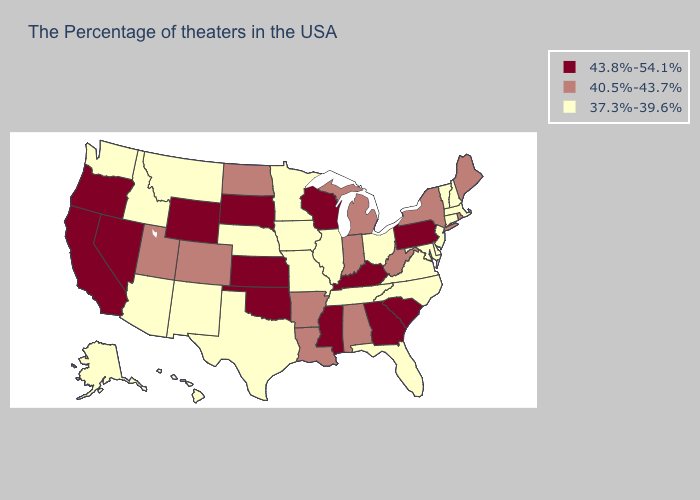Among the states that border Indiana , does Michigan have the lowest value?
Answer briefly. No. How many symbols are there in the legend?
Concise answer only. 3. Does the map have missing data?
Answer briefly. No. Among the states that border New Jersey , which have the highest value?
Write a very short answer. Pennsylvania. Does the map have missing data?
Answer briefly. No. Does the map have missing data?
Concise answer only. No. Name the states that have a value in the range 37.3%-39.6%?
Quick response, please. Massachusetts, New Hampshire, Vermont, Connecticut, New Jersey, Delaware, Maryland, Virginia, North Carolina, Ohio, Florida, Tennessee, Illinois, Missouri, Minnesota, Iowa, Nebraska, Texas, New Mexico, Montana, Arizona, Idaho, Washington, Alaska, Hawaii. What is the value of Hawaii?
Give a very brief answer. 37.3%-39.6%. Name the states that have a value in the range 40.5%-43.7%?
Be succinct. Maine, Rhode Island, New York, West Virginia, Michigan, Indiana, Alabama, Louisiana, Arkansas, North Dakota, Colorado, Utah. Name the states that have a value in the range 37.3%-39.6%?
Short answer required. Massachusetts, New Hampshire, Vermont, Connecticut, New Jersey, Delaware, Maryland, Virginia, North Carolina, Ohio, Florida, Tennessee, Illinois, Missouri, Minnesota, Iowa, Nebraska, Texas, New Mexico, Montana, Arizona, Idaho, Washington, Alaska, Hawaii. Name the states that have a value in the range 37.3%-39.6%?
Short answer required. Massachusetts, New Hampshire, Vermont, Connecticut, New Jersey, Delaware, Maryland, Virginia, North Carolina, Ohio, Florida, Tennessee, Illinois, Missouri, Minnesota, Iowa, Nebraska, Texas, New Mexico, Montana, Arizona, Idaho, Washington, Alaska, Hawaii. Name the states that have a value in the range 40.5%-43.7%?
Short answer required. Maine, Rhode Island, New York, West Virginia, Michigan, Indiana, Alabama, Louisiana, Arkansas, North Dakota, Colorado, Utah. Which states have the lowest value in the MidWest?
Answer briefly. Ohio, Illinois, Missouri, Minnesota, Iowa, Nebraska. What is the lowest value in the Northeast?
Answer briefly. 37.3%-39.6%. 